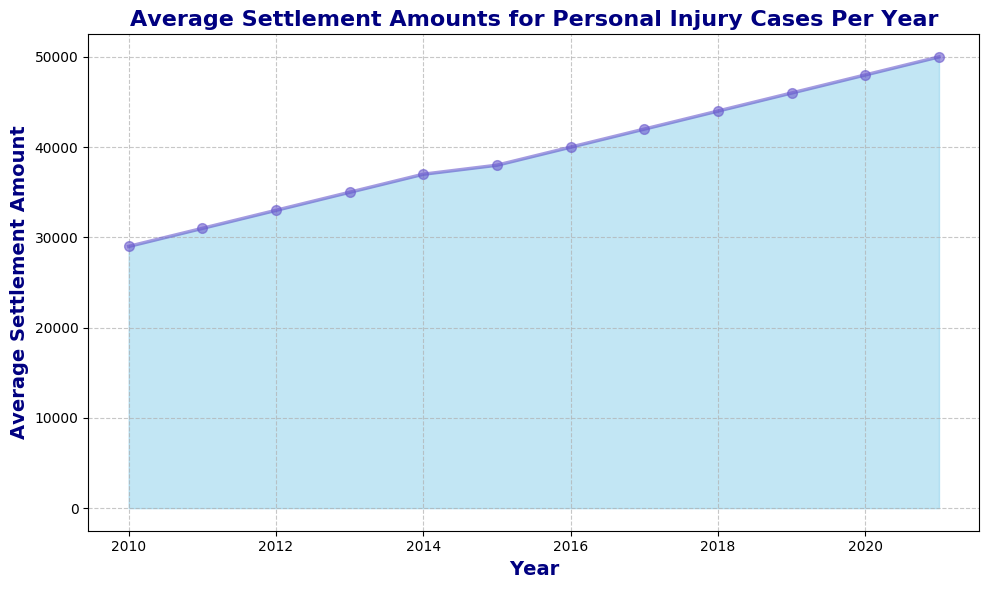What's the trend in the average settlement amounts from 2010 to 2021? The overall trend in the average settlement amounts can be observed by looking at the direction and steepness of the plotted line between 2010 and 2021. The line steadily rises, indicating an upward trend over the years.
Answer: Upward Which year had the highest average settlement amount? By looking at the peak of the plot, we can identify the year with the highest value on the y-axis. The peak of the plot is in the year 2021 with the highest value.
Answer: 2021 What is the average settlement amount difference between 2010 and 2021? Subtract the average settlement amount of 2010 from that of 2021. The amount in 2010 is $29,000 and in 2021 is $50,000. $50,000 - $29,000 = $21,000.
Answer: $21,000 How many consecutive years had an increase in average settlement amounts? By observing the plot, from 2010 to 2021, each year shows an increase from the previous year, making it 11 consecutive years of increase.
Answer: 11 years What is the combined average settlement amount for the years 2015 and 2020? Add the values for 2015 and 2020. The amount for 2015 is $38,000 and for 2020 is $48,000. $38,000 + $48,000 = $86,000.
Answer: $86,000 In which year did the average settlement amount first exceed $40,000? Look for the point where the line first surpasses $40,000 on the y-axis. This happened in 2016.
Answer: 2016 Compare the average settlement amounts of 2013 and 2019. Which year had a higher value and by how much? The value in 2013 is $35,000 and in 2019 is $46,000. $46,000 - $35,000 gives a difference of $11,000 in favor of 2019.
Answer: 2019 by $11,000 How much did the average settlement amount increase from 2014 to 2018? Subtract the 2014 amount from the 2018 amount. The values are $37,000 and $44,000 respectively. $44,000 - $37,000 = $7,000.
Answer: $7,000 What are the visual indications that there was consistent growth in settlement amounts? The steady upward slope of the filled area and line from left (2010) to right (2021) visually indicates consistent growth in the average settlement amounts. The absence of any dips or flat segments confirms this steady growth.
Answer: Steady upward slope, no dips Which two consecutive years have the smallest increase in average settlement amounts? Compare the vertical differences between each pair of consecutive years. The smallest difference is between 2014 ($37,000) and 2015 ($38,000), which is $1,000.
Answer: 2014-2015, $1,000 